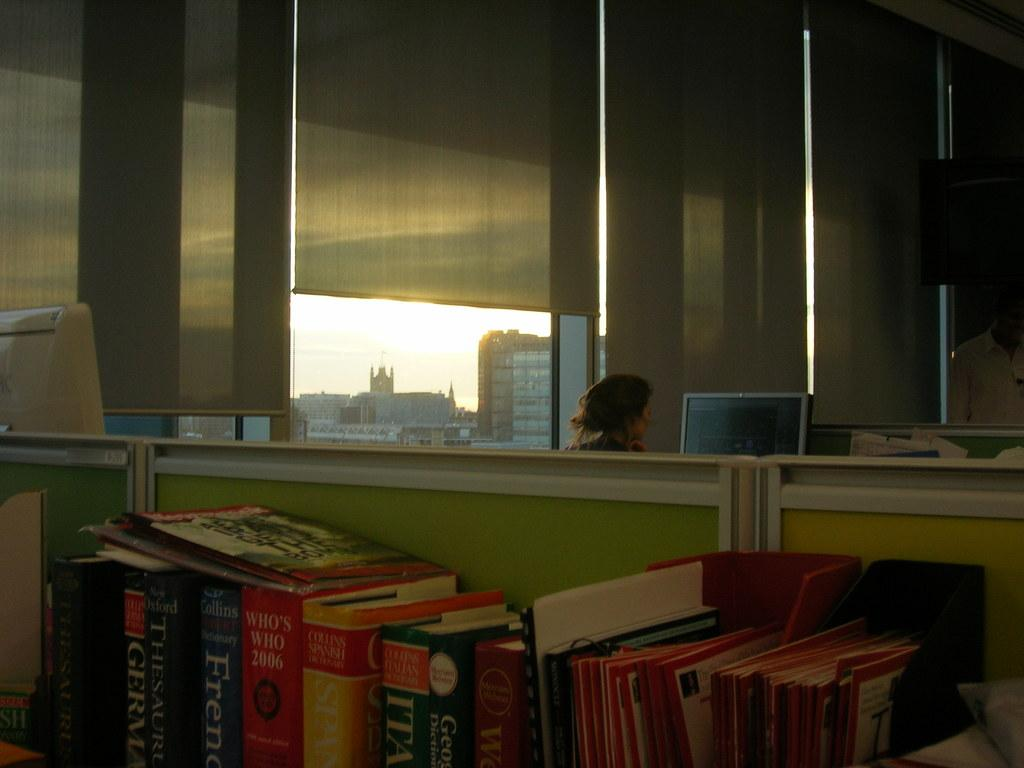<image>
Describe the image concisely. Library with a woman that is working on a computer, and book shelf containing different books, like a Thesaurus. 